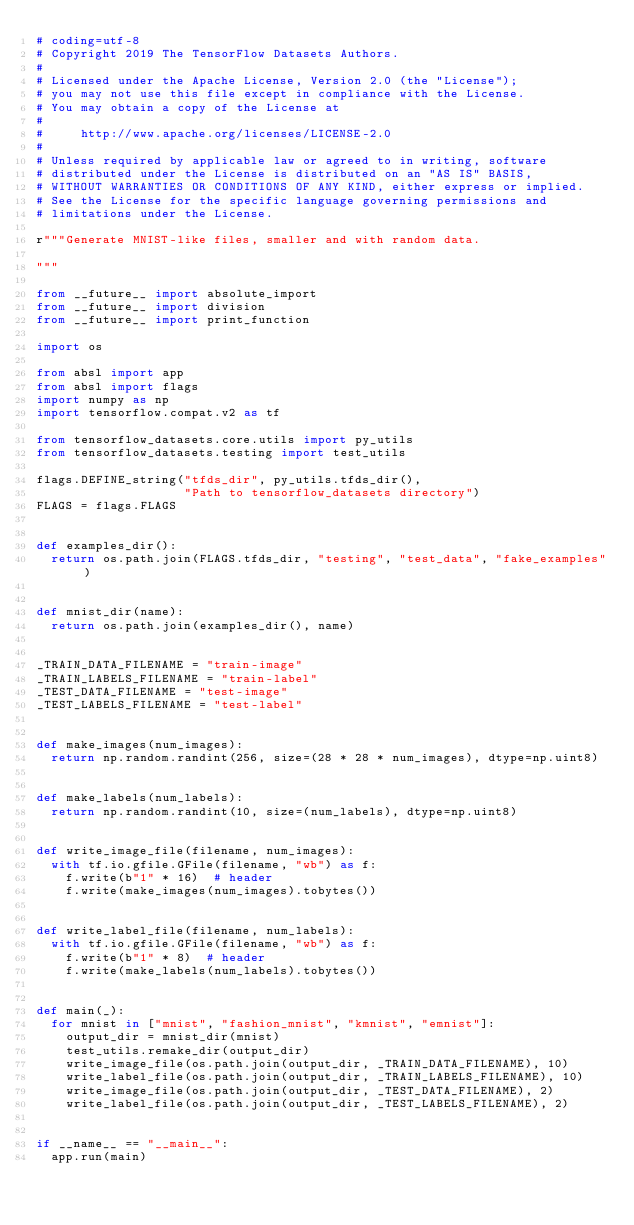Convert code to text. <code><loc_0><loc_0><loc_500><loc_500><_Python_># coding=utf-8
# Copyright 2019 The TensorFlow Datasets Authors.
#
# Licensed under the Apache License, Version 2.0 (the "License");
# you may not use this file except in compliance with the License.
# You may obtain a copy of the License at
#
#     http://www.apache.org/licenses/LICENSE-2.0
#
# Unless required by applicable law or agreed to in writing, software
# distributed under the License is distributed on an "AS IS" BASIS,
# WITHOUT WARRANTIES OR CONDITIONS OF ANY KIND, either express or implied.
# See the License for the specific language governing permissions and
# limitations under the License.

r"""Generate MNIST-like files, smaller and with random data.

"""

from __future__ import absolute_import
from __future__ import division
from __future__ import print_function

import os

from absl import app
from absl import flags
import numpy as np
import tensorflow.compat.v2 as tf

from tensorflow_datasets.core.utils import py_utils
from tensorflow_datasets.testing import test_utils

flags.DEFINE_string("tfds_dir", py_utils.tfds_dir(),
                    "Path to tensorflow_datasets directory")
FLAGS = flags.FLAGS


def examples_dir():
  return os.path.join(FLAGS.tfds_dir, "testing", "test_data", "fake_examples")


def mnist_dir(name):
  return os.path.join(examples_dir(), name)


_TRAIN_DATA_FILENAME = "train-image"
_TRAIN_LABELS_FILENAME = "train-label"
_TEST_DATA_FILENAME = "test-image"
_TEST_LABELS_FILENAME = "test-label"


def make_images(num_images):
  return np.random.randint(256, size=(28 * 28 * num_images), dtype=np.uint8)


def make_labels(num_labels):
  return np.random.randint(10, size=(num_labels), dtype=np.uint8)


def write_image_file(filename, num_images):
  with tf.io.gfile.GFile(filename, "wb") as f:
    f.write(b"1" * 16)  # header
    f.write(make_images(num_images).tobytes())


def write_label_file(filename, num_labels):
  with tf.io.gfile.GFile(filename, "wb") as f:
    f.write(b"1" * 8)  # header
    f.write(make_labels(num_labels).tobytes())


def main(_):
  for mnist in ["mnist", "fashion_mnist", "kmnist", "emnist"]:
    output_dir = mnist_dir(mnist)
    test_utils.remake_dir(output_dir)
    write_image_file(os.path.join(output_dir, _TRAIN_DATA_FILENAME), 10)
    write_label_file(os.path.join(output_dir, _TRAIN_LABELS_FILENAME), 10)
    write_image_file(os.path.join(output_dir, _TEST_DATA_FILENAME), 2)
    write_label_file(os.path.join(output_dir, _TEST_LABELS_FILENAME), 2)


if __name__ == "__main__":
  app.run(main)
</code> 